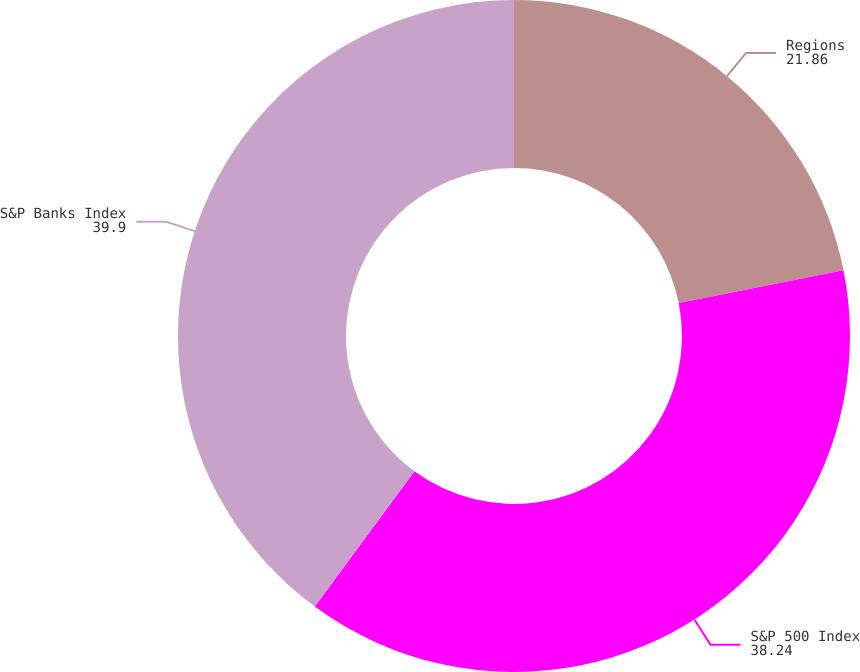Convert chart to OTSL. <chart><loc_0><loc_0><loc_500><loc_500><pie_chart><fcel>Regions<fcel>S&P 500 Index<fcel>S&P Banks Index<nl><fcel>21.86%<fcel>38.24%<fcel>39.9%<nl></chart> 